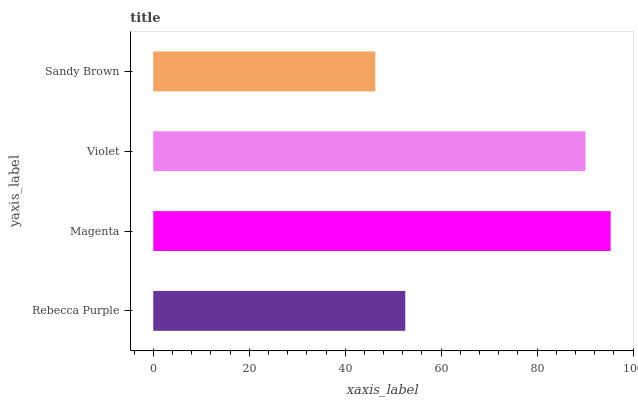Is Sandy Brown the minimum?
Answer yes or no. Yes. Is Magenta the maximum?
Answer yes or no. Yes. Is Violet the minimum?
Answer yes or no. No. Is Violet the maximum?
Answer yes or no. No. Is Magenta greater than Violet?
Answer yes or no. Yes. Is Violet less than Magenta?
Answer yes or no. Yes. Is Violet greater than Magenta?
Answer yes or no. No. Is Magenta less than Violet?
Answer yes or no. No. Is Violet the high median?
Answer yes or no. Yes. Is Rebecca Purple the low median?
Answer yes or no. Yes. Is Sandy Brown the high median?
Answer yes or no. No. Is Violet the low median?
Answer yes or no. No. 